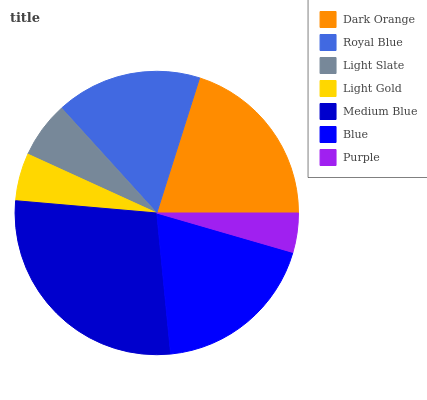Is Purple the minimum?
Answer yes or no. Yes. Is Medium Blue the maximum?
Answer yes or no. Yes. Is Royal Blue the minimum?
Answer yes or no. No. Is Royal Blue the maximum?
Answer yes or no. No. Is Dark Orange greater than Royal Blue?
Answer yes or no. Yes. Is Royal Blue less than Dark Orange?
Answer yes or no. Yes. Is Royal Blue greater than Dark Orange?
Answer yes or no. No. Is Dark Orange less than Royal Blue?
Answer yes or no. No. Is Royal Blue the high median?
Answer yes or no. Yes. Is Royal Blue the low median?
Answer yes or no. Yes. Is Dark Orange the high median?
Answer yes or no. No. Is Medium Blue the low median?
Answer yes or no. No. 